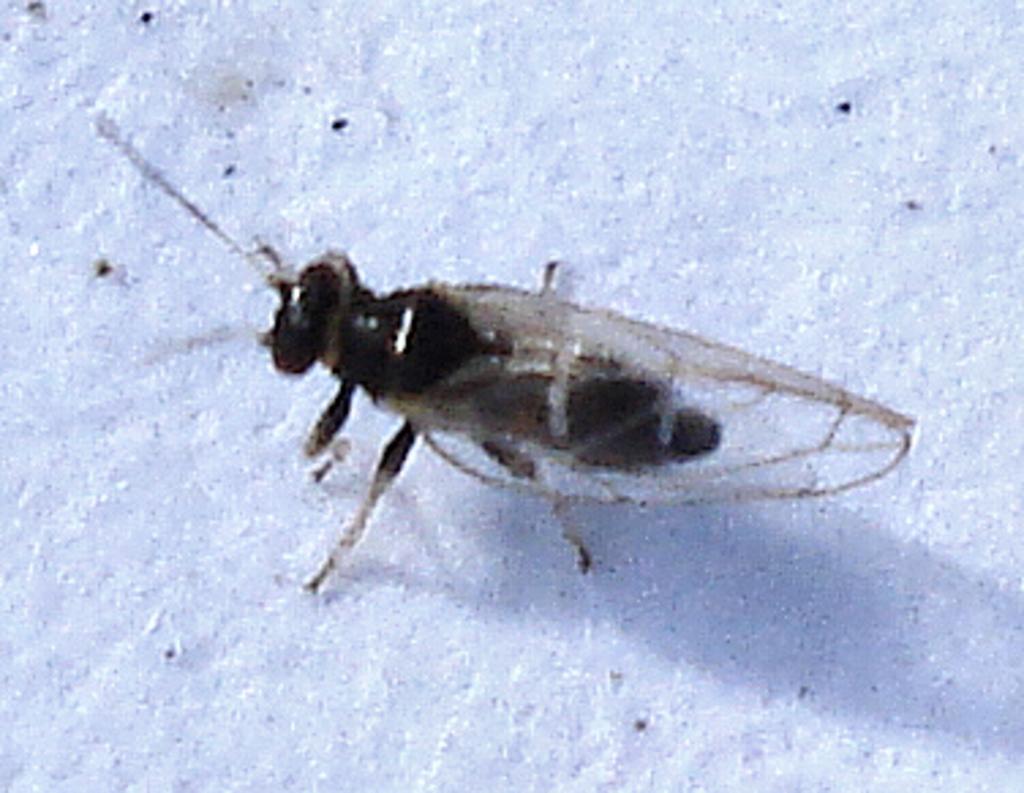How would you summarize this image in a sentence or two? In the center of the image a housefly is present. 